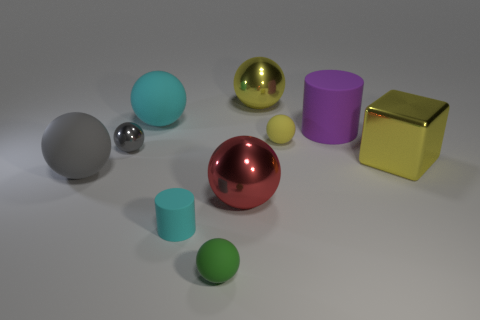Subtract all cyan balls. How many balls are left? 6 Subtract all gray spheres. How many spheres are left? 5 Subtract 1 blocks. How many blocks are left? 0 Subtract all brown balls. How many gray cylinders are left? 0 Subtract all green matte things. Subtract all blocks. How many objects are left? 8 Add 2 rubber balls. How many rubber balls are left? 6 Add 9 cyan matte balls. How many cyan matte balls exist? 10 Subtract 0 brown blocks. How many objects are left? 10 Subtract all cylinders. How many objects are left? 8 Subtract all blue spheres. Subtract all green cylinders. How many spheres are left? 7 